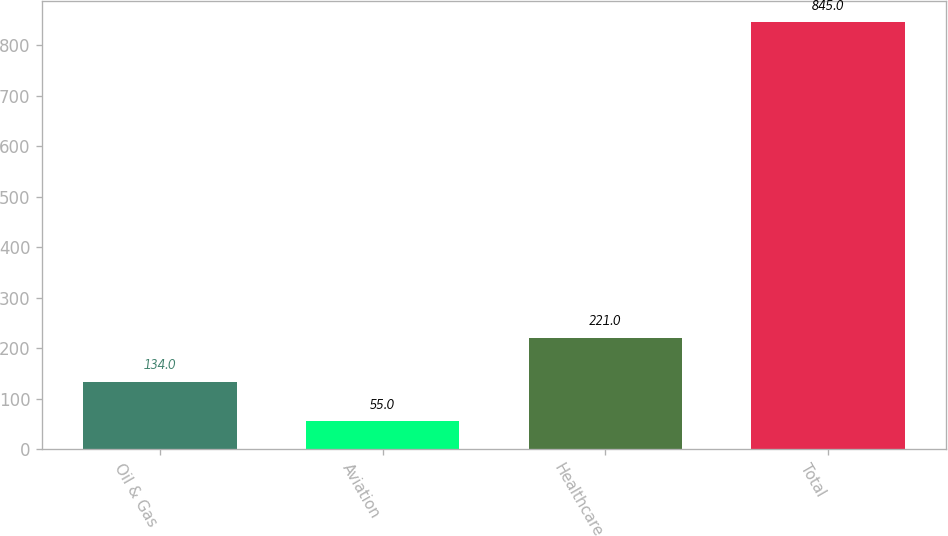<chart> <loc_0><loc_0><loc_500><loc_500><bar_chart><fcel>Oil & Gas<fcel>Aviation<fcel>Healthcare<fcel>Total<nl><fcel>134<fcel>55<fcel>221<fcel>845<nl></chart> 